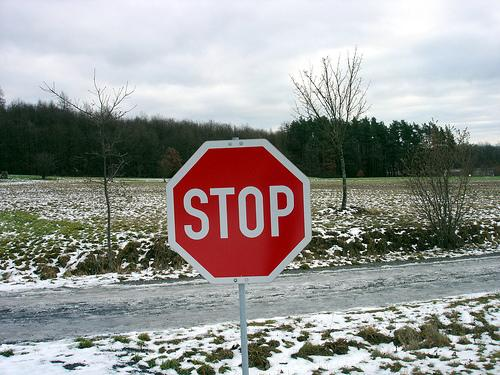Describe the condition of the grass in the image. The grass in the image is partially covered with snow, peeking through the white powder in some areas. Relate an observation about the snow in the scene. There are sparse snowy patches on the ground, with some grass and plants covered in a light dusting of snow. Express a sentiment about the road situated between the fields. The road between the fields gives off an air of serenity, surrounded by the stark beauty of the winter landscape. Briefly describe the overall setting of the image. The image portrays a winter landscape with a stop sign, bare trees, snow-covered fields, and a road between two fields. Mention one noteworthy characteristic about the stop sign in the image. The stop sign in the image has white lettering against a red background and is mounted on a grey metal post. List the most prominent objects in the scene. A red and white stop sign, a pole holding the sign, a tree without leaves, a snow-covered field, and a road between two fields. Mention the color of the sign and describe the text on it. The sign is red with white letters that spell out "STOP." Write a short statement about the clouds seen in the sky. The sky features fluffy white clouds dispersed across the gray, overcast backdrop. Write a sentence describing the state of the trees in the image. The trees in the image are leafless, standing tall along the road and the edge of the snow-covered field. Tell me what the weather appears to be like in the image. The weather in the image appears to be cold and overcast, with white cloudy skies and a blanket of snow on the ground. 